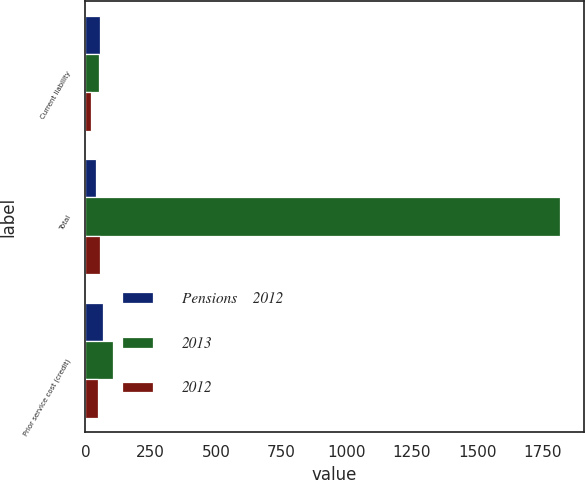Convert chart to OTSL. <chart><loc_0><loc_0><loc_500><loc_500><stacked_bar_chart><ecel><fcel>Current liability<fcel>Total<fcel>Prior service cost (credit)<nl><fcel>Pensions    2012<fcel>58<fcel>40<fcel>67<nl><fcel>2013<fcel>53<fcel>1817<fcel>105<nl><fcel>2012<fcel>23<fcel>55.5<fcel>47<nl></chart> 